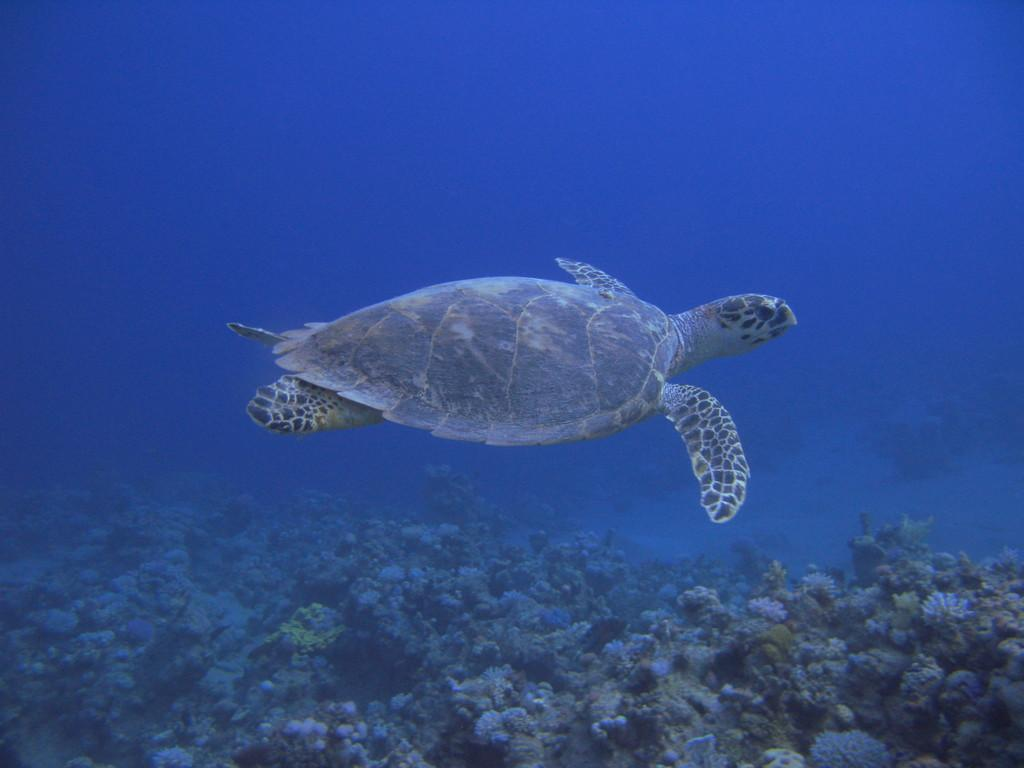Where was the image taken? The image is taken in the sea. What can be seen at the bottom of the image? There are coral reefs at the bottom of the image. What animal is in the middle of the image? There is a turtle in the middle of the image. What type of unit is attached to the turtle's shell in the image? There is no unit attached to the turtle's shell in the image. Can you see a locket hanging from the coral reefs in the image? There is no locket present in the image; it features a turtle and coral reefs in the sea. 